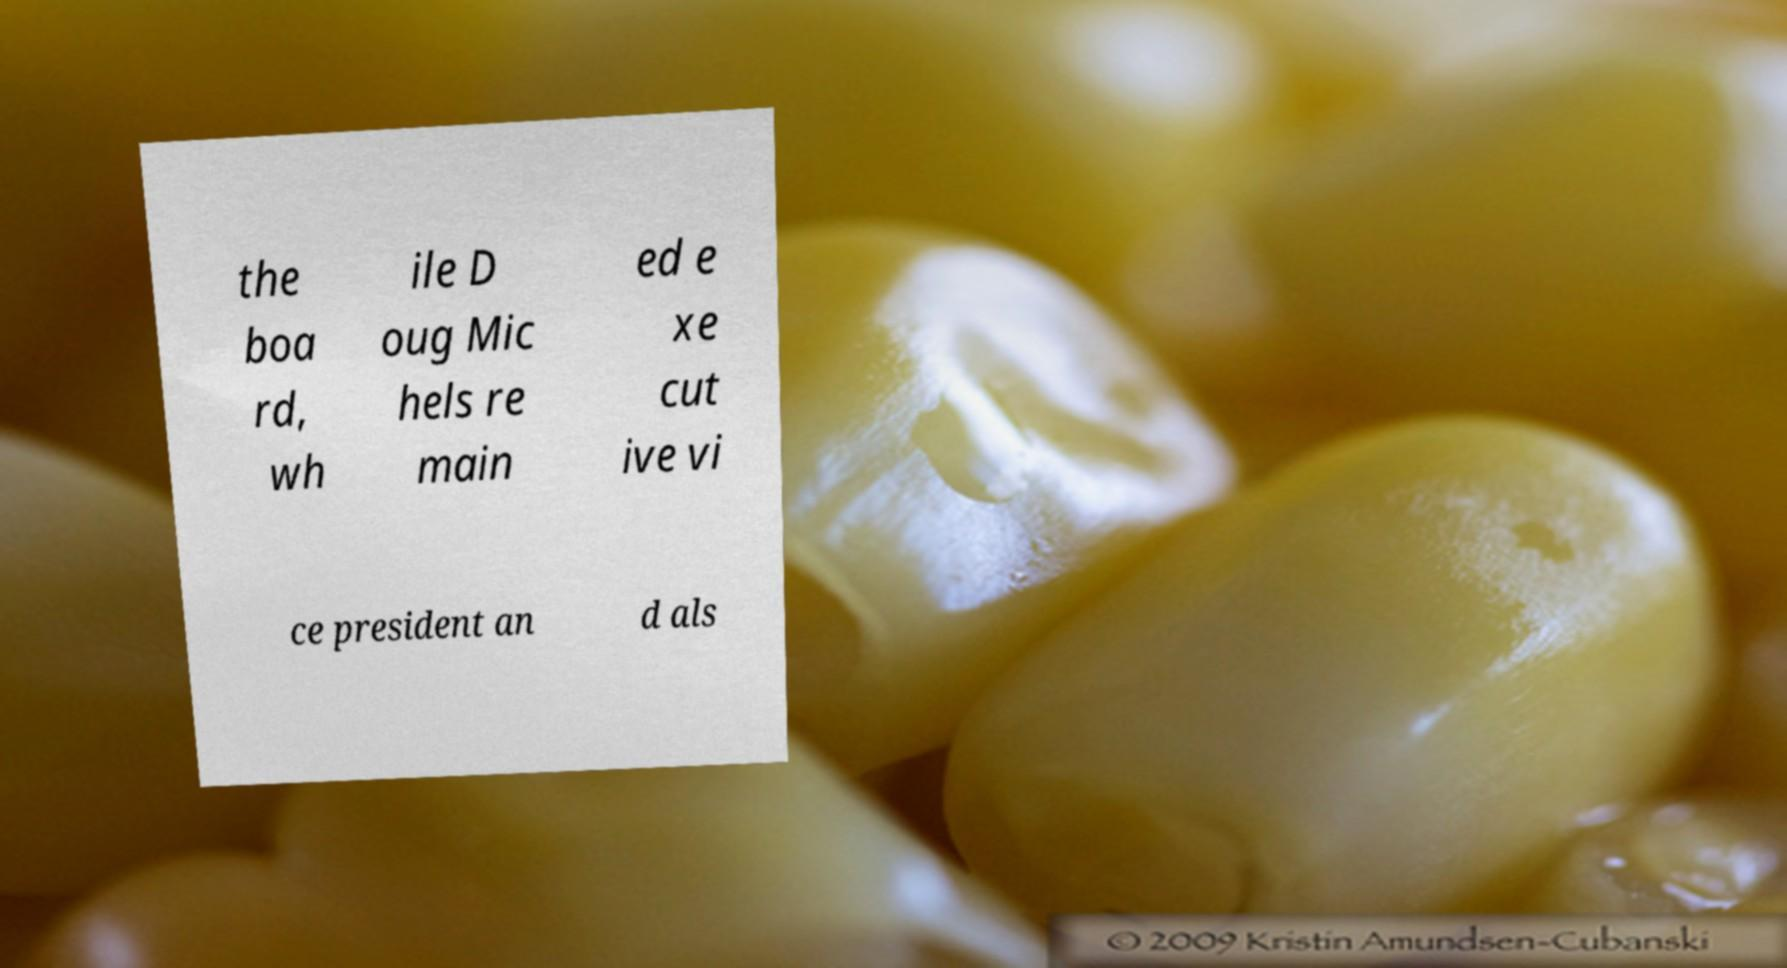What messages or text are displayed in this image? I need them in a readable, typed format. the boa rd, wh ile D oug Mic hels re main ed e xe cut ive vi ce president an d als 